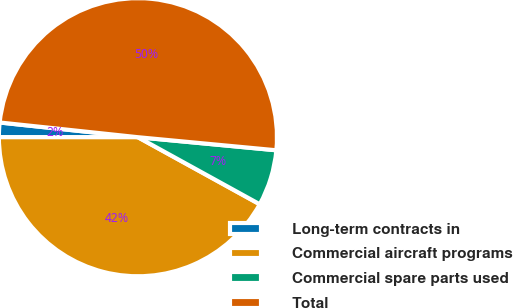<chart> <loc_0><loc_0><loc_500><loc_500><pie_chart><fcel>Long-term contracts in<fcel>Commercial aircraft programs<fcel>Commercial spare parts used<fcel>Total<nl><fcel>1.69%<fcel>41.99%<fcel>6.51%<fcel>49.81%<nl></chart> 